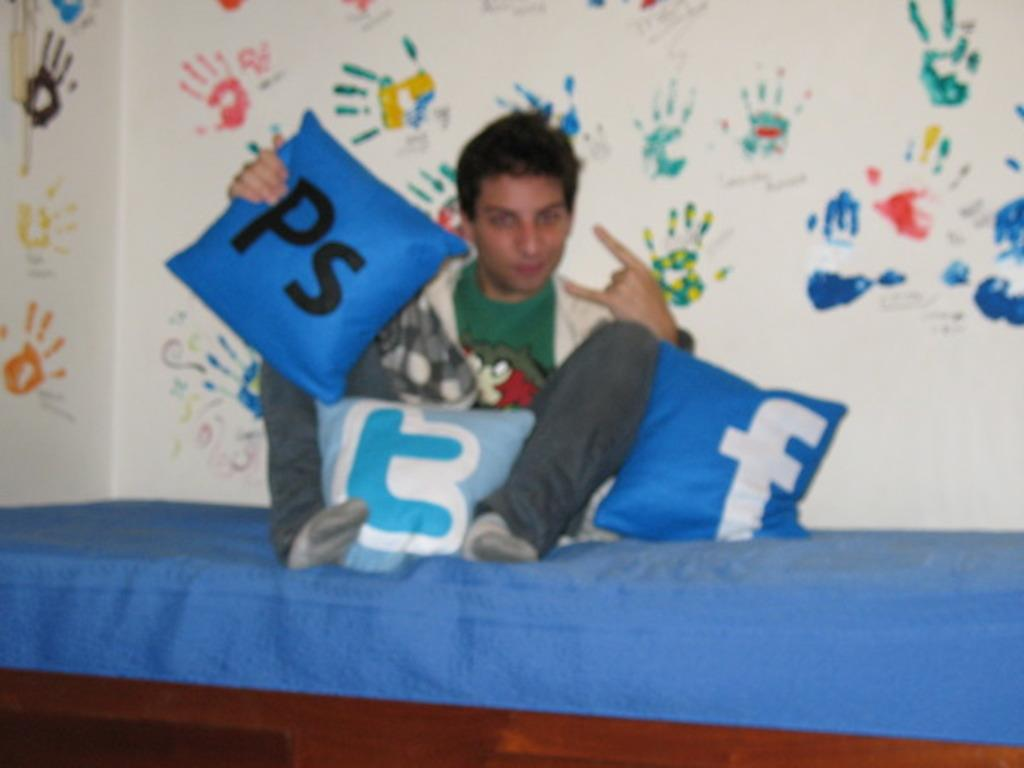Provide a one-sentence caption for the provided image. A young man sits on a bed with pillows with social media and application icons on pillows around him. 